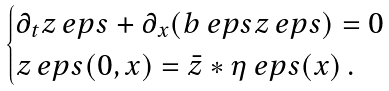<formula> <loc_0><loc_0><loc_500><loc_500>\begin{cases} \partial _ { t } z _ { \ } e p s + \partial _ { x } ( b _ { \ } e p s z _ { \ } e p s ) = 0 \\ z _ { \ } e p s ( 0 , x ) = \bar { z } * \eta _ { \ } e p s ( x ) \, . \end{cases}</formula> 